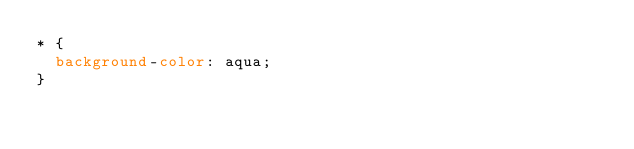Convert code to text. <code><loc_0><loc_0><loc_500><loc_500><_CSS_>* {
  background-color: aqua;
}</code> 